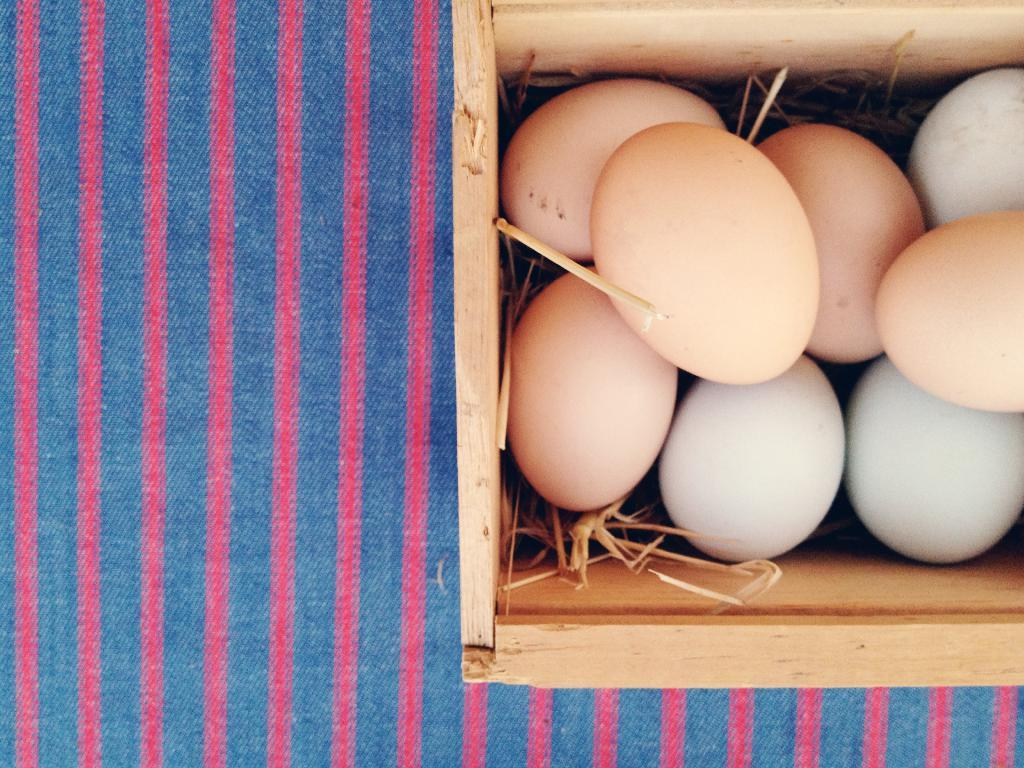What object is the main focus of the image? There is a wooden box in the image. What is inside the wooden box? The wooden box contains eggs. What type of surface is under the eggs? There is grass under the eggs. What is placed under the wooden box? There is a cloth under the wooden box. Is the wooden box being used to cook the eggs in the image? No, the wooden box is not being used to cook the eggs in the image; it is simply a container for them. 